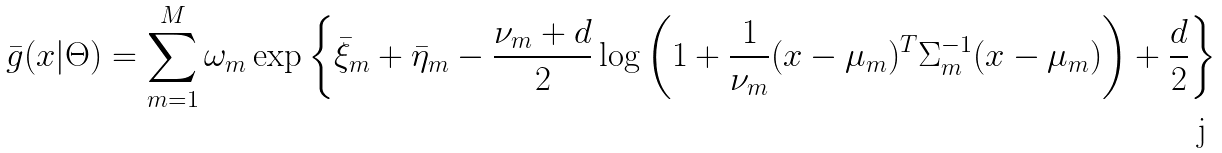Convert formula to latex. <formula><loc_0><loc_0><loc_500><loc_500>\bar { g } ( x | \Theta ) = \sum _ { m = 1 } ^ { M } \omega _ { m } \exp \left \{ \bar { \xi } _ { m } + \bar { \eta } _ { m } - \frac { \nu _ { m } + d } { 2 } \log \left ( 1 + \frac { 1 } { \nu _ { m } } ( x - \mu _ { m } ) ^ { T } \Sigma _ { m } ^ { - 1 } ( x - \mu _ { m } ) \right ) + \frac { d } { 2 } \right \}</formula> 